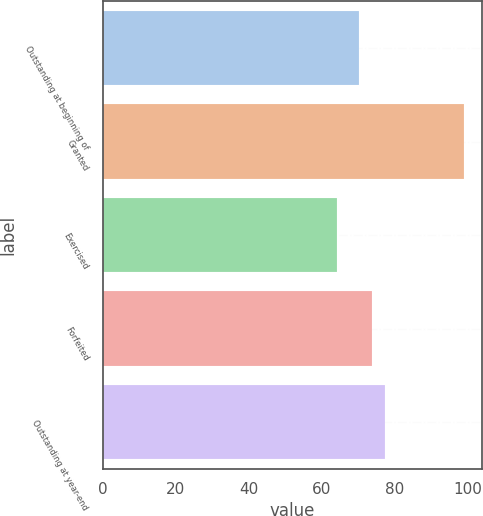Convert chart. <chart><loc_0><loc_0><loc_500><loc_500><bar_chart><fcel>Outstanding at beginning of<fcel>Granted<fcel>Exercised<fcel>Forfeited<fcel>Outstanding at year-end<nl><fcel>70.33<fcel>99.04<fcel>64.19<fcel>73.81<fcel>77.3<nl></chart> 